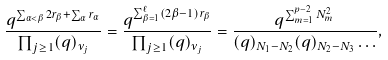<formula> <loc_0><loc_0><loc_500><loc_500>\frac { q ^ { \sum _ { \alpha < \beta } 2 r _ { \beta } + \sum _ { \alpha } r _ { \alpha } } } { \prod _ { j \geq 1 } ( q ) _ { \nu _ { j } } } = \frac { q ^ { \sum _ { \beta = 1 } ^ { \ell } ( 2 \beta - 1 ) r _ { \beta } } } { \prod _ { j \geq 1 } ( q ) _ { \nu _ { j } } } = \frac { q ^ { \sum _ { m = 1 } ^ { p - 2 } N _ { m } ^ { 2 } } } { ( q ) _ { N _ { 1 } - N _ { 2 } } ( q ) _ { N _ { 2 } - N _ { 3 } } \dots } ,</formula> 